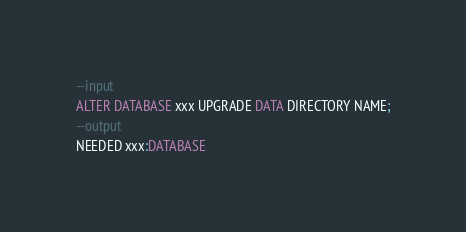Convert code to text. <code><loc_0><loc_0><loc_500><loc_500><_SQL_>--input
ALTER DATABASE xxx UPGRADE DATA DIRECTORY NAME;
--output
NEEDED xxx:DATABASE</code> 